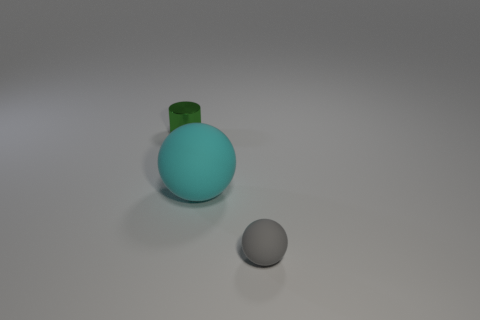What number of other objects are there of the same material as the gray sphere?
Offer a terse response. 1. What size is the thing that is in front of the large matte sphere?
Your answer should be very brief. Small. What is the shape of the gray thing that is made of the same material as the large cyan object?
Give a very brief answer. Sphere. Is the material of the gray sphere the same as the cyan object that is on the left side of the small gray thing?
Your answer should be very brief. Yes. What color is the thing that is both to the right of the green object and behind the gray rubber ball?
Your answer should be compact. Cyan. What number of other things are the same shape as the tiny green thing?
Provide a short and direct response. 0. The metallic object is what shape?
Provide a short and direct response. Cylinder. Does the cyan object have the same material as the gray thing?
Your answer should be very brief. Yes. Are there an equal number of small green metallic things that are behind the tiny cylinder and small matte things on the right side of the small gray matte object?
Give a very brief answer. Yes. There is a small object that is right of the tiny object to the left of the cyan object; are there any tiny things on the left side of it?
Ensure brevity in your answer.  Yes. 